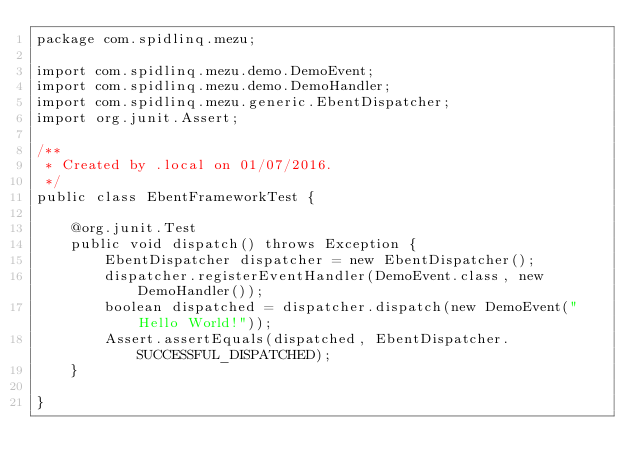<code> <loc_0><loc_0><loc_500><loc_500><_Java_>package com.spidlinq.mezu;

import com.spidlinq.mezu.demo.DemoEvent;
import com.spidlinq.mezu.demo.DemoHandler;
import com.spidlinq.mezu.generic.EbentDispatcher;
import org.junit.Assert;

/**
 * Created by .local on 01/07/2016.
 */
public class EbentFrameworkTest {

    @org.junit.Test
    public void dispatch() throws Exception {
        EbentDispatcher dispatcher = new EbentDispatcher();
        dispatcher.registerEventHandler(DemoEvent.class, new DemoHandler());
        boolean dispatched = dispatcher.dispatch(new DemoEvent("Hello World!"));
        Assert.assertEquals(dispatched, EbentDispatcher.SUCCESSFUL_DISPATCHED);
    }

}</code> 